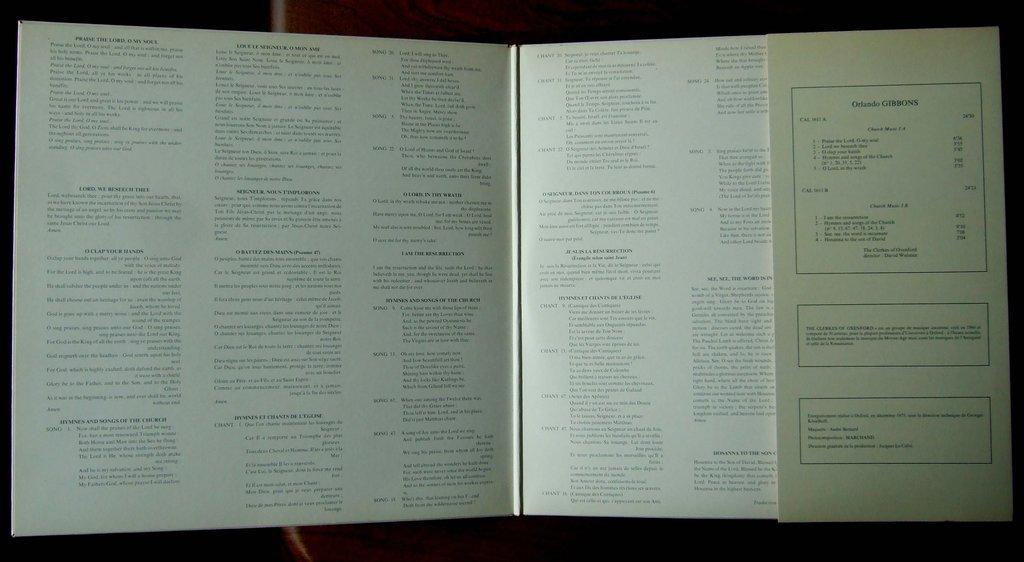Provide a one-sentence caption for the provided image. A open book with the words Praise the Lord at the top of the left pafe. 